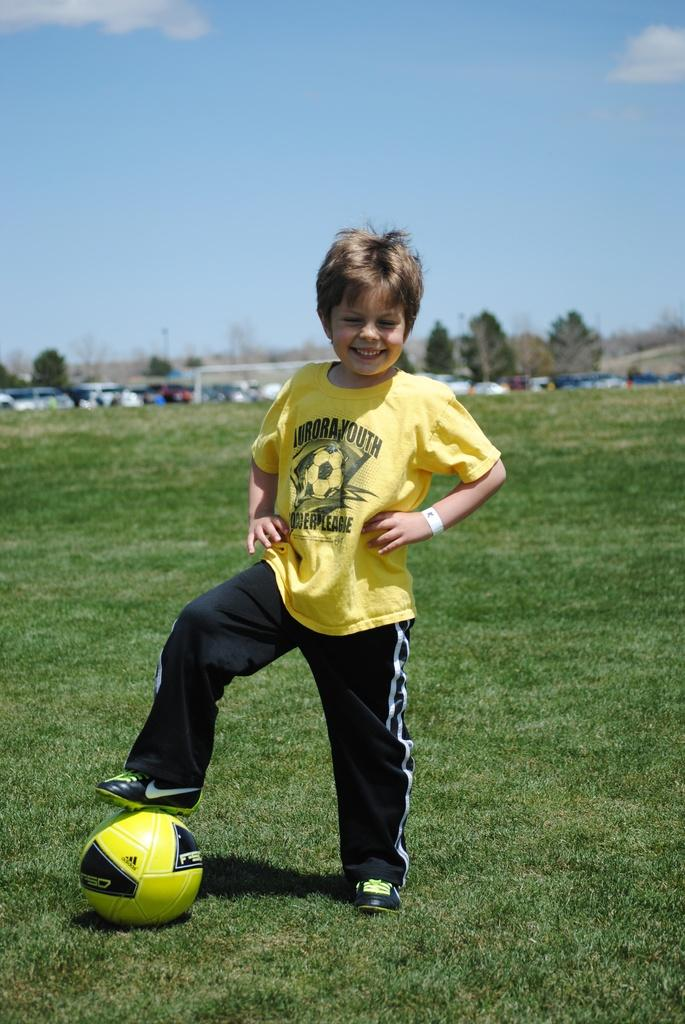<image>
Present a compact description of the photo's key features. A young player for Aurora Youth Soccer League 